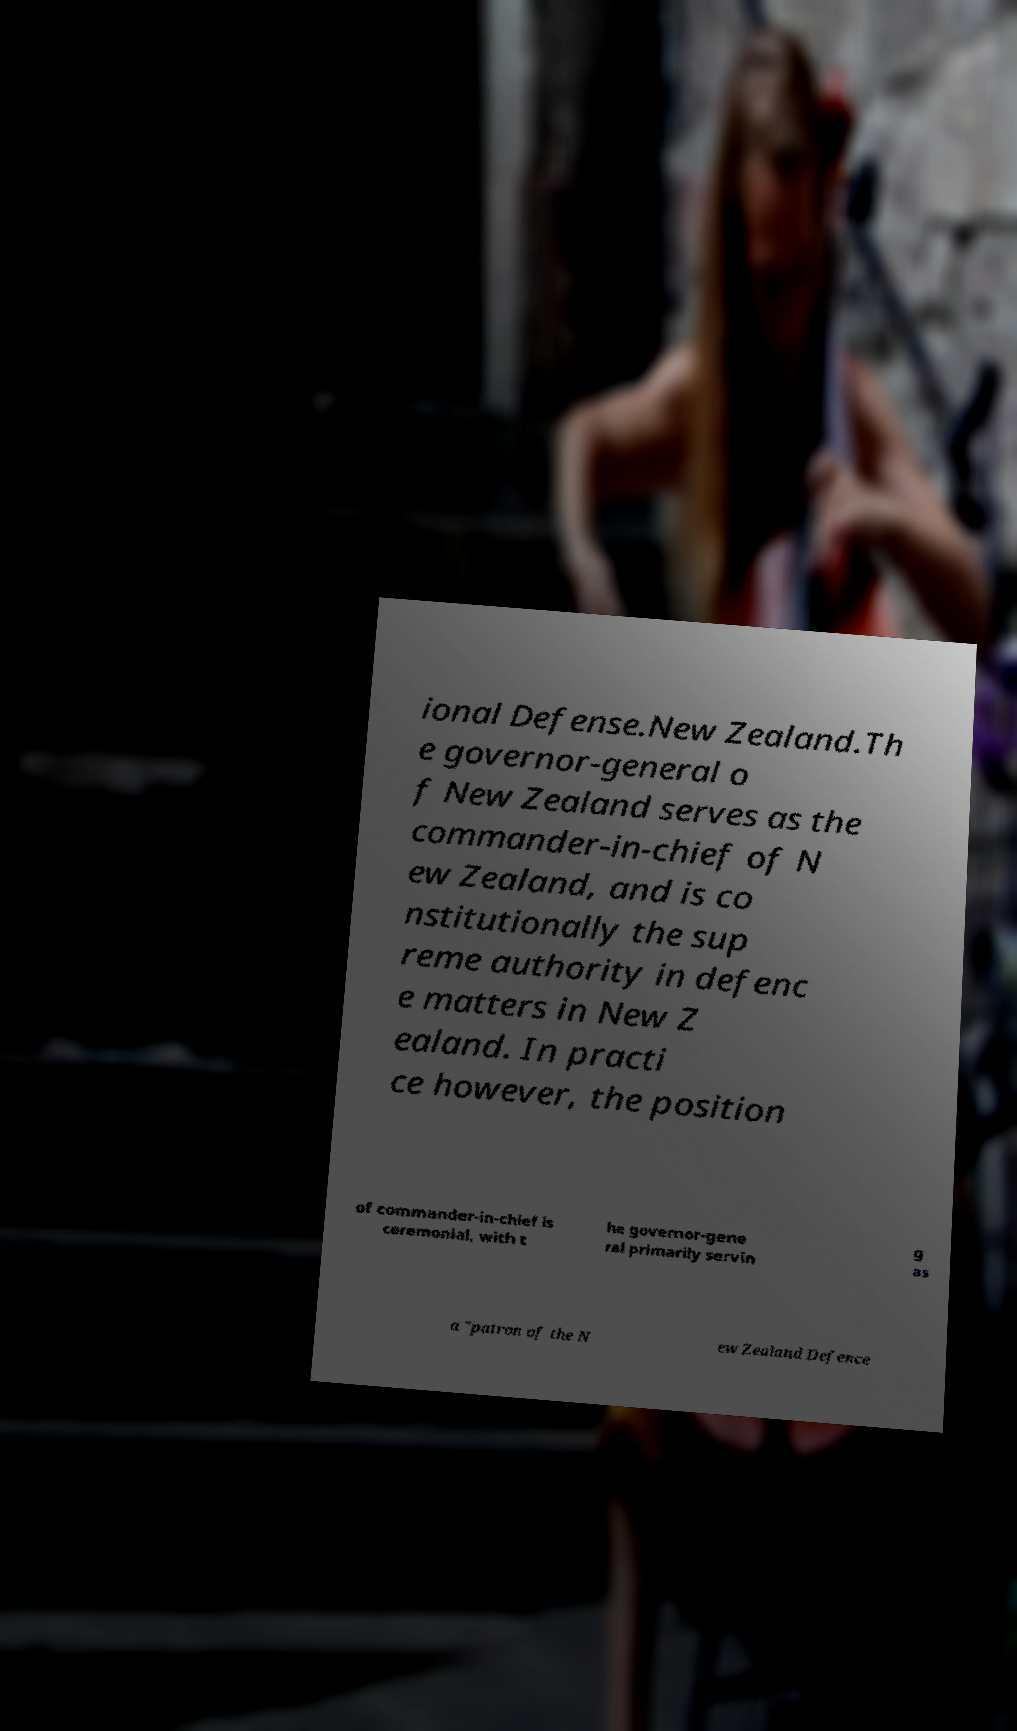For documentation purposes, I need the text within this image transcribed. Could you provide that? ional Defense.New Zealand.Th e governor-general o f New Zealand serves as the commander-in-chief of N ew Zealand, and is co nstitutionally the sup reme authority in defenc e matters in New Z ealand. In practi ce however, the position of commander-in-chief is ceremonial, with t he governor-gene ral primarily servin g as a "patron of the N ew Zealand Defence 